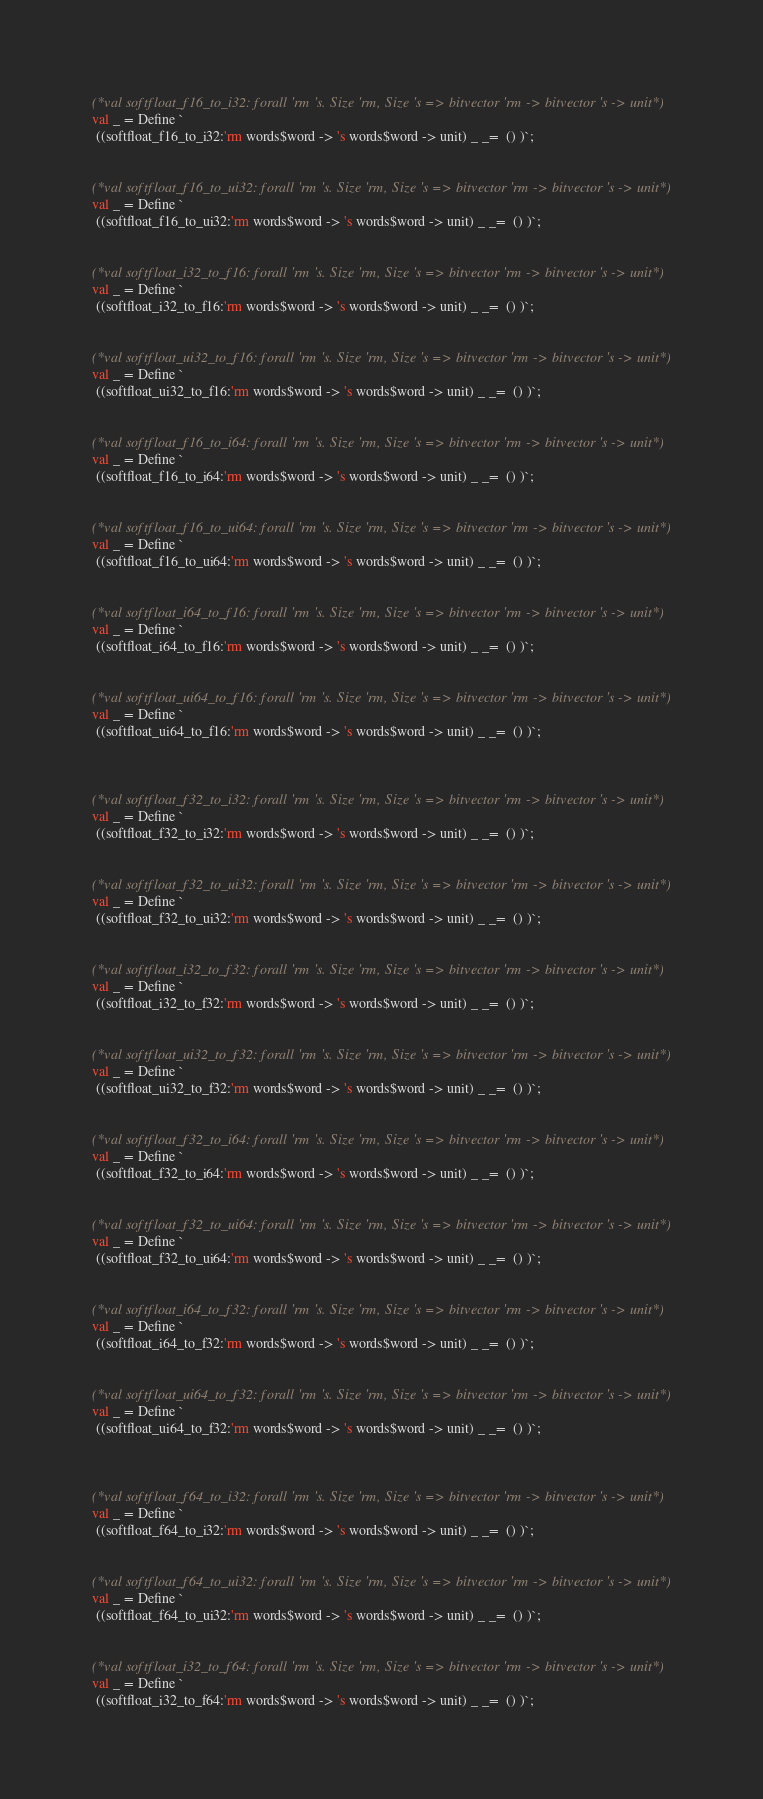<code> <loc_0><loc_0><loc_500><loc_500><_SML_>

(*val softfloat_f16_to_i32: forall 'rm 's. Size 'rm, Size 's => bitvector 'rm -> bitvector 's -> unit*)
val _ = Define `
 ((softfloat_f16_to_i32:'rm words$word -> 's words$word -> unit) _ _=  () )`;


(*val softfloat_f16_to_ui32: forall 'rm 's. Size 'rm, Size 's => bitvector 'rm -> bitvector 's -> unit*)
val _ = Define `
 ((softfloat_f16_to_ui32:'rm words$word -> 's words$word -> unit) _ _=  () )`;


(*val softfloat_i32_to_f16: forall 'rm 's. Size 'rm, Size 's => bitvector 'rm -> bitvector 's -> unit*)
val _ = Define `
 ((softfloat_i32_to_f16:'rm words$word -> 's words$word -> unit) _ _=  () )`;


(*val softfloat_ui32_to_f16: forall 'rm 's. Size 'rm, Size 's => bitvector 'rm -> bitvector 's -> unit*)
val _ = Define `
 ((softfloat_ui32_to_f16:'rm words$word -> 's words$word -> unit) _ _=  () )`;


(*val softfloat_f16_to_i64: forall 'rm 's. Size 'rm, Size 's => bitvector 'rm -> bitvector 's -> unit*)
val _ = Define `
 ((softfloat_f16_to_i64:'rm words$word -> 's words$word -> unit) _ _=  () )`;


(*val softfloat_f16_to_ui64: forall 'rm 's. Size 'rm, Size 's => bitvector 'rm -> bitvector 's -> unit*)
val _ = Define `
 ((softfloat_f16_to_ui64:'rm words$word -> 's words$word -> unit) _ _=  () )`;


(*val softfloat_i64_to_f16: forall 'rm 's. Size 'rm, Size 's => bitvector 'rm -> bitvector 's -> unit*)
val _ = Define `
 ((softfloat_i64_to_f16:'rm words$word -> 's words$word -> unit) _ _=  () )`;


(*val softfloat_ui64_to_f16: forall 'rm 's. Size 'rm, Size 's => bitvector 'rm -> bitvector 's -> unit*)
val _ = Define `
 ((softfloat_ui64_to_f16:'rm words$word -> 's words$word -> unit) _ _=  () )`;



(*val softfloat_f32_to_i32: forall 'rm 's. Size 'rm, Size 's => bitvector 'rm -> bitvector 's -> unit*)
val _ = Define `
 ((softfloat_f32_to_i32:'rm words$word -> 's words$word -> unit) _ _=  () )`;


(*val softfloat_f32_to_ui32: forall 'rm 's. Size 'rm, Size 's => bitvector 'rm -> bitvector 's -> unit*)
val _ = Define `
 ((softfloat_f32_to_ui32:'rm words$word -> 's words$word -> unit) _ _=  () )`;


(*val softfloat_i32_to_f32: forall 'rm 's. Size 'rm, Size 's => bitvector 'rm -> bitvector 's -> unit*)
val _ = Define `
 ((softfloat_i32_to_f32:'rm words$word -> 's words$word -> unit) _ _=  () )`;


(*val softfloat_ui32_to_f32: forall 'rm 's. Size 'rm, Size 's => bitvector 'rm -> bitvector 's -> unit*)
val _ = Define `
 ((softfloat_ui32_to_f32:'rm words$word -> 's words$word -> unit) _ _=  () )`;


(*val softfloat_f32_to_i64: forall 'rm 's. Size 'rm, Size 's => bitvector 'rm -> bitvector 's -> unit*)
val _ = Define `
 ((softfloat_f32_to_i64:'rm words$word -> 's words$word -> unit) _ _=  () )`;


(*val softfloat_f32_to_ui64: forall 'rm 's. Size 'rm, Size 's => bitvector 'rm -> bitvector 's -> unit*)
val _ = Define `
 ((softfloat_f32_to_ui64:'rm words$word -> 's words$word -> unit) _ _=  () )`;


(*val softfloat_i64_to_f32: forall 'rm 's. Size 'rm, Size 's => bitvector 'rm -> bitvector 's -> unit*)
val _ = Define `
 ((softfloat_i64_to_f32:'rm words$word -> 's words$word -> unit) _ _=  () )`;


(*val softfloat_ui64_to_f32: forall 'rm 's. Size 'rm, Size 's => bitvector 'rm -> bitvector 's -> unit*)
val _ = Define `
 ((softfloat_ui64_to_f32:'rm words$word -> 's words$word -> unit) _ _=  () )`;



(*val softfloat_f64_to_i32: forall 'rm 's. Size 'rm, Size 's => bitvector 'rm -> bitvector 's -> unit*)
val _ = Define `
 ((softfloat_f64_to_i32:'rm words$word -> 's words$word -> unit) _ _=  () )`;


(*val softfloat_f64_to_ui32: forall 'rm 's. Size 'rm, Size 's => bitvector 'rm -> bitvector 's -> unit*)
val _ = Define `
 ((softfloat_f64_to_ui32:'rm words$word -> 's words$word -> unit) _ _=  () )`;


(*val softfloat_i32_to_f64: forall 'rm 's. Size 'rm, Size 's => bitvector 'rm -> bitvector 's -> unit*)
val _ = Define `
 ((softfloat_i32_to_f64:'rm words$word -> 's words$word -> unit) _ _=  () )`;

</code> 